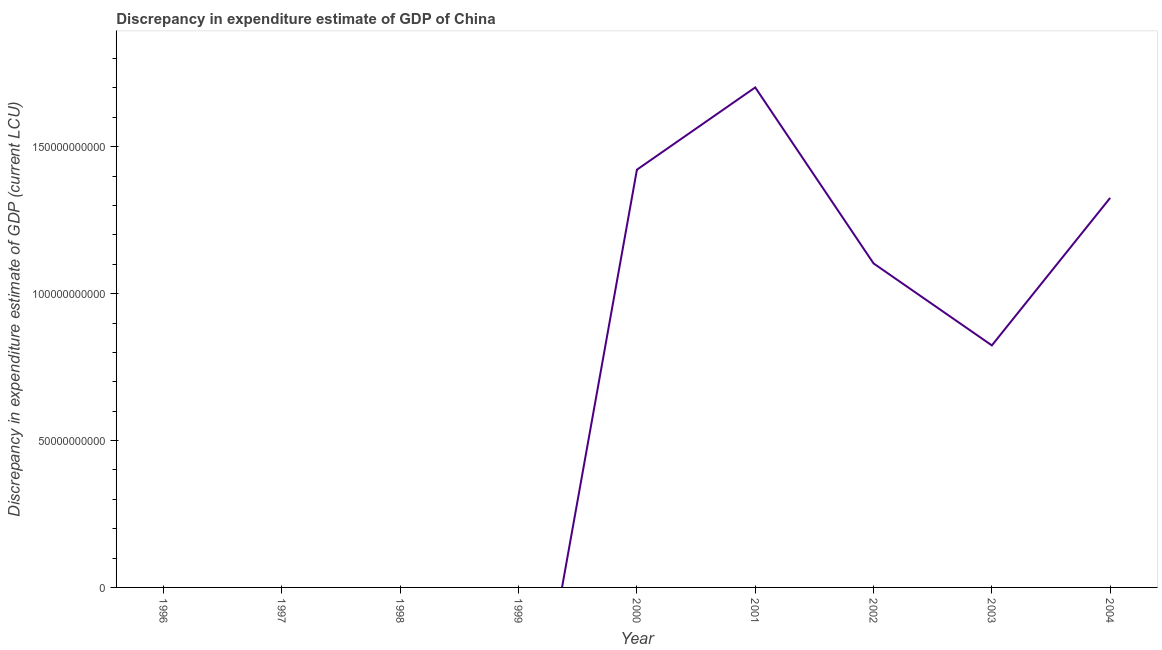What is the discrepancy in expenditure estimate of gdp in 2003?
Your answer should be very brief. 8.24e+1. Across all years, what is the maximum discrepancy in expenditure estimate of gdp?
Make the answer very short. 1.70e+11. What is the sum of the discrepancy in expenditure estimate of gdp?
Give a very brief answer. 6.38e+11. What is the difference between the discrepancy in expenditure estimate of gdp in 2002 and 2003?
Your answer should be very brief. 2.79e+1. What is the average discrepancy in expenditure estimate of gdp per year?
Give a very brief answer. 7.08e+1. What is the median discrepancy in expenditure estimate of gdp?
Make the answer very short. 8.24e+1. In how many years, is the discrepancy in expenditure estimate of gdp greater than 10000000000 LCU?
Your answer should be compact. 5. What is the ratio of the discrepancy in expenditure estimate of gdp in 2000 to that in 2004?
Make the answer very short. 1.07. Is the discrepancy in expenditure estimate of gdp in 2000 less than that in 2004?
Give a very brief answer. No. What is the difference between the highest and the second highest discrepancy in expenditure estimate of gdp?
Keep it short and to the point. 2.80e+1. Is the sum of the discrepancy in expenditure estimate of gdp in 2002 and 2004 greater than the maximum discrepancy in expenditure estimate of gdp across all years?
Keep it short and to the point. Yes. What is the difference between the highest and the lowest discrepancy in expenditure estimate of gdp?
Provide a short and direct response. 1.70e+11. In how many years, is the discrepancy in expenditure estimate of gdp greater than the average discrepancy in expenditure estimate of gdp taken over all years?
Make the answer very short. 5. Does the discrepancy in expenditure estimate of gdp monotonically increase over the years?
Keep it short and to the point. No. How many years are there in the graph?
Ensure brevity in your answer.  9. What is the title of the graph?
Provide a short and direct response. Discrepancy in expenditure estimate of GDP of China. What is the label or title of the X-axis?
Provide a short and direct response. Year. What is the label or title of the Y-axis?
Give a very brief answer. Discrepancy in expenditure estimate of GDP (current LCU). What is the Discrepancy in expenditure estimate of GDP (current LCU) in 1998?
Give a very brief answer. 0. What is the Discrepancy in expenditure estimate of GDP (current LCU) in 1999?
Make the answer very short. 0. What is the Discrepancy in expenditure estimate of GDP (current LCU) in 2000?
Keep it short and to the point. 1.42e+11. What is the Discrepancy in expenditure estimate of GDP (current LCU) of 2001?
Provide a short and direct response. 1.70e+11. What is the Discrepancy in expenditure estimate of GDP (current LCU) of 2002?
Offer a very short reply. 1.10e+11. What is the Discrepancy in expenditure estimate of GDP (current LCU) in 2003?
Offer a terse response. 8.24e+1. What is the Discrepancy in expenditure estimate of GDP (current LCU) in 2004?
Make the answer very short. 1.33e+11. What is the difference between the Discrepancy in expenditure estimate of GDP (current LCU) in 2000 and 2001?
Ensure brevity in your answer.  -2.80e+1. What is the difference between the Discrepancy in expenditure estimate of GDP (current LCU) in 2000 and 2002?
Offer a terse response. 3.19e+1. What is the difference between the Discrepancy in expenditure estimate of GDP (current LCU) in 2000 and 2003?
Your answer should be very brief. 5.98e+1. What is the difference between the Discrepancy in expenditure estimate of GDP (current LCU) in 2000 and 2004?
Provide a succinct answer. 9.60e+09. What is the difference between the Discrepancy in expenditure estimate of GDP (current LCU) in 2001 and 2002?
Offer a terse response. 5.99e+1. What is the difference between the Discrepancy in expenditure estimate of GDP (current LCU) in 2001 and 2003?
Provide a short and direct response. 8.78e+1. What is the difference between the Discrepancy in expenditure estimate of GDP (current LCU) in 2001 and 2004?
Give a very brief answer. 3.76e+1. What is the difference between the Discrepancy in expenditure estimate of GDP (current LCU) in 2002 and 2003?
Provide a short and direct response. 2.79e+1. What is the difference between the Discrepancy in expenditure estimate of GDP (current LCU) in 2002 and 2004?
Ensure brevity in your answer.  -2.23e+1. What is the difference between the Discrepancy in expenditure estimate of GDP (current LCU) in 2003 and 2004?
Your answer should be very brief. -5.02e+1. What is the ratio of the Discrepancy in expenditure estimate of GDP (current LCU) in 2000 to that in 2001?
Keep it short and to the point. 0.83. What is the ratio of the Discrepancy in expenditure estimate of GDP (current LCU) in 2000 to that in 2002?
Offer a very short reply. 1.29. What is the ratio of the Discrepancy in expenditure estimate of GDP (current LCU) in 2000 to that in 2003?
Provide a short and direct response. 1.73. What is the ratio of the Discrepancy in expenditure estimate of GDP (current LCU) in 2000 to that in 2004?
Offer a very short reply. 1.07. What is the ratio of the Discrepancy in expenditure estimate of GDP (current LCU) in 2001 to that in 2002?
Your answer should be compact. 1.54. What is the ratio of the Discrepancy in expenditure estimate of GDP (current LCU) in 2001 to that in 2003?
Your response must be concise. 2.07. What is the ratio of the Discrepancy in expenditure estimate of GDP (current LCU) in 2001 to that in 2004?
Offer a very short reply. 1.28. What is the ratio of the Discrepancy in expenditure estimate of GDP (current LCU) in 2002 to that in 2003?
Your response must be concise. 1.34. What is the ratio of the Discrepancy in expenditure estimate of GDP (current LCU) in 2002 to that in 2004?
Provide a succinct answer. 0.83. What is the ratio of the Discrepancy in expenditure estimate of GDP (current LCU) in 2003 to that in 2004?
Provide a short and direct response. 0.62. 